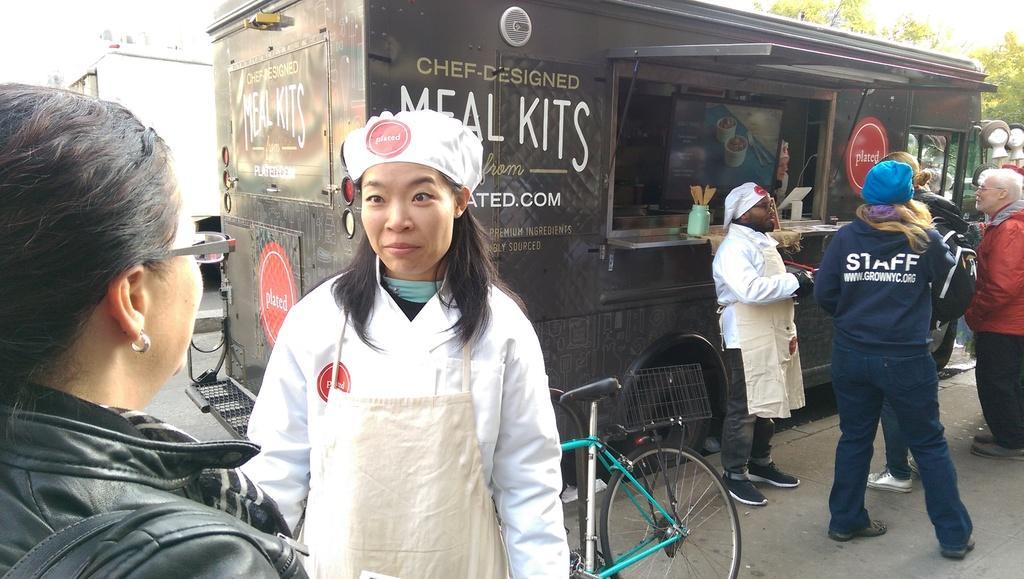Could you give a brief overview of what you see in this image? In front of the picture, we see two women are standing. The woman in the white apron is standing and she is smiling. Behind her, we see a bicycle. On the right side, we see four people are standing. In front of them, we see a food truck in black color with some text written on it. On the left side, we see a building in white color. There are trees in the background. 